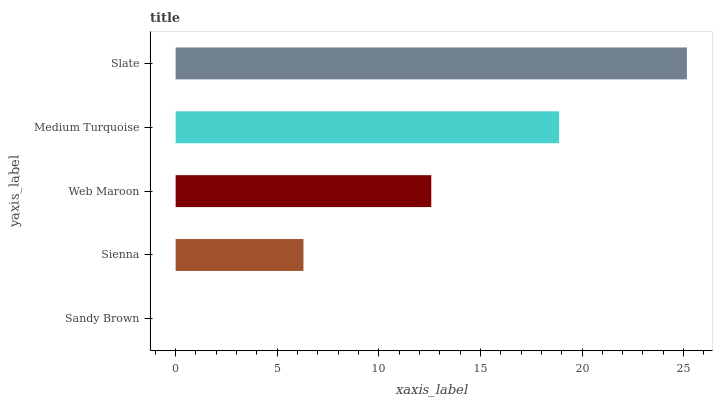Is Sandy Brown the minimum?
Answer yes or no. Yes. Is Slate the maximum?
Answer yes or no. Yes. Is Sienna the minimum?
Answer yes or no. No. Is Sienna the maximum?
Answer yes or no. No. Is Sienna greater than Sandy Brown?
Answer yes or no. Yes. Is Sandy Brown less than Sienna?
Answer yes or no. Yes. Is Sandy Brown greater than Sienna?
Answer yes or no. No. Is Sienna less than Sandy Brown?
Answer yes or no. No. Is Web Maroon the high median?
Answer yes or no. Yes. Is Web Maroon the low median?
Answer yes or no. Yes. Is Sienna the high median?
Answer yes or no. No. Is Slate the low median?
Answer yes or no. No. 